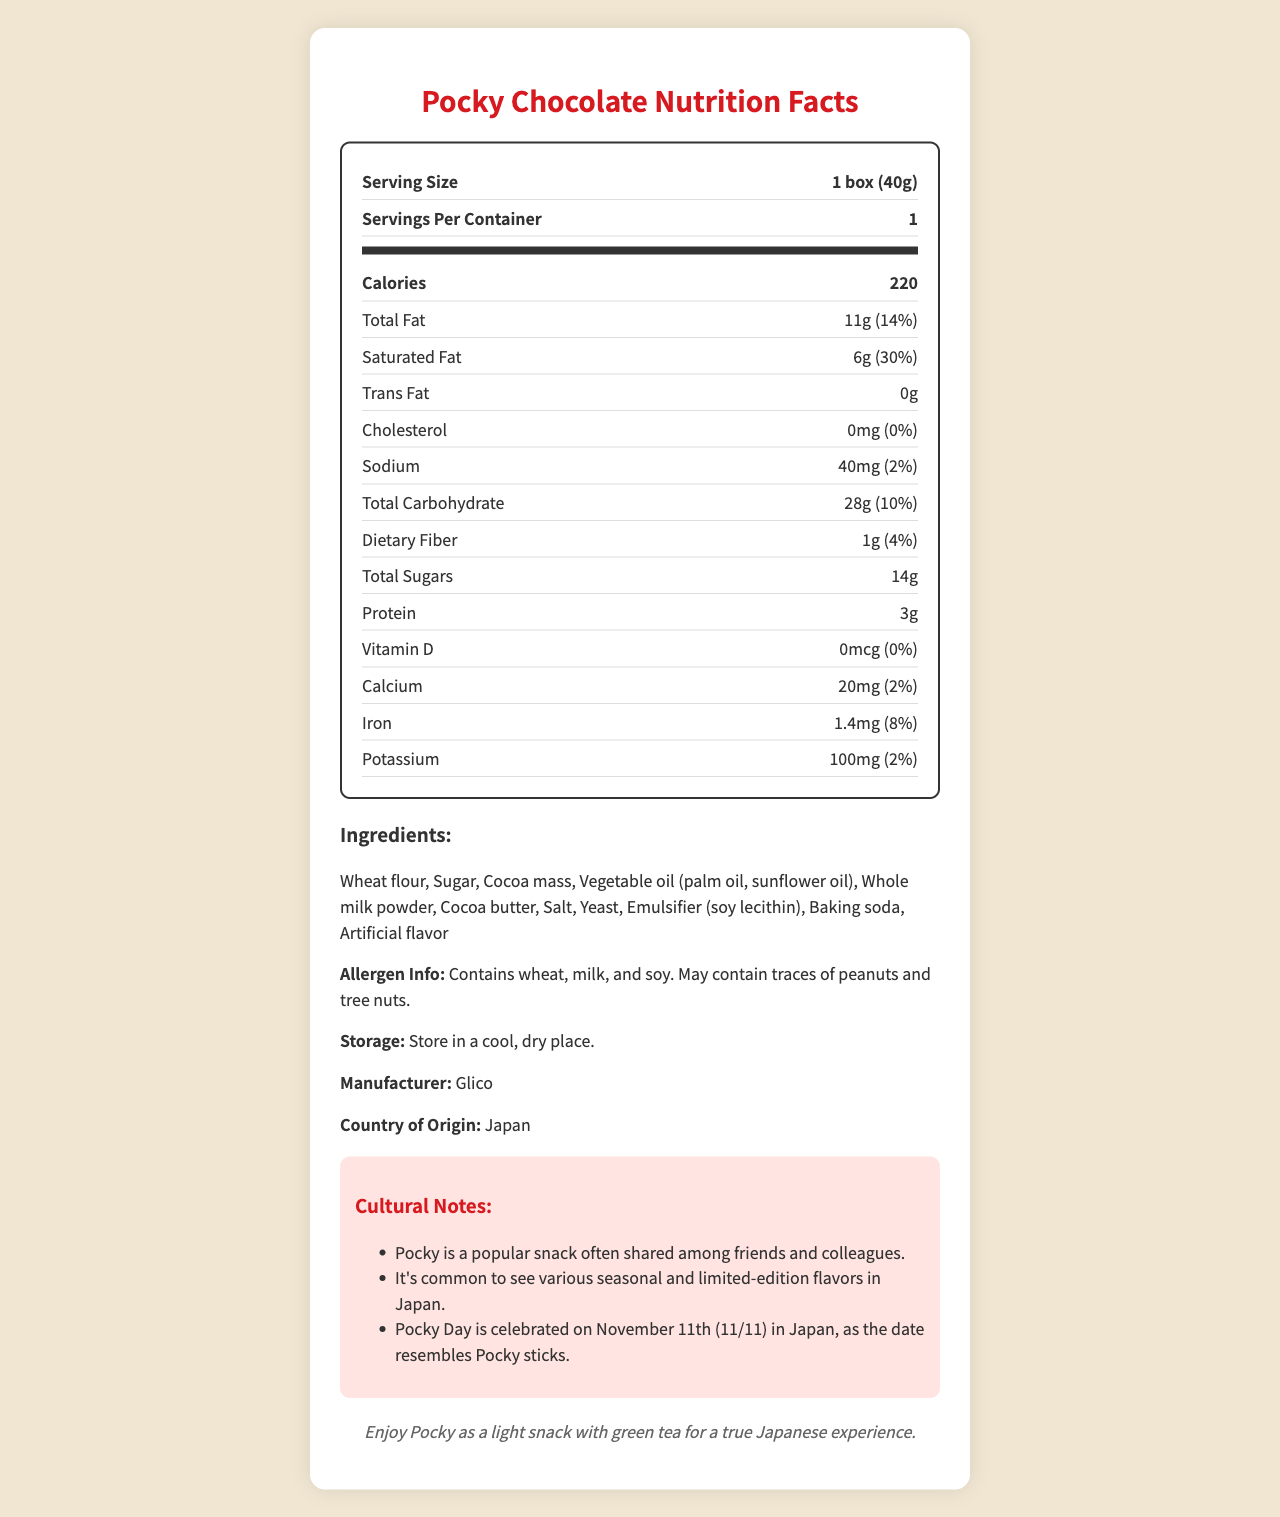what is the serving size? The serving size is stated at the top of the nutrition label: "Serving Size 1 box (40g)".
Answer: 1 box (40g) how many calories are in one serving of Pocky Chocolate? The calories per serving are listed as "220" under the Calories section of the nutrition label.
Answer: 220 what is the total fat content in one serving? The total fat content is specified as "Total Fat 11g (14%)".
Answer: 11g compare the saturated fat and trans fat content in Pocky Chocolate. The nutrition label shows "Saturated Fat 6g (30%)" and "Trans Fat 0g".
Answer: Saturated Fat: 6g, Trans Fat: 0g what are the ingredients in Pocky Chocolate? The ingredients are listed under the Ingredients section of the document.
Answer: Wheat flour, Sugar, Cocoa mass, Vegetable oil (palm oil, sunflower oil), Whole milk powder, Cocoa butter, Salt, Yeast, Emulsifier (soy lecithin), Baking soda, Artificial flavor what allergens are present in Pocky Chocolate? The allergen information states: "Contains wheat, milk, and soy. May contain traces of peanuts and tree nuts."
Answer: wheat, milk, soy, may contain traces of peanuts and tree nuts who is the manufacturer of Pocky Chocolate? The manufacturer information is given as "Glico".
Answer: Glico what is the fiber content per serving? The dietary fiber content is shown in the nutrition facts as "Dietary Fiber 1g (4%)".
Answer: 1g how much protein is in one serving of Pocky Chocolate? The protein content is listed as "Protein 3g" in the nutrition label.
Answer: 3g how much sodium does one serving contain? The sodium content is stated as "Sodium 40mg (2%)".
Answer: 40mg which vitamin is not present in Pocky Chocolate? The nutrition label shows "Vitamin D 0mcg (0%)", indicating that Vitamin D is not present.
Answer: Vitamin D what are the total carbohydrates in a serving? The total carbohydrate content is listed as "Total Carbohydrate 28g (10%)".
Answer: 28g which ingredient is not part of Pocky Chocolate? A. Wheat flour B. Cocoa mass C. Potato starch D. Yeast The ingredients listed include Wheat flour, Cocoa mass, and Yeast, but not Potato starch.
Answer: C. Potato starch how is Pocky typically enjoyed according to the document? A. With a meal B. As a light snack with green tea C. Before bedtime D. With coffee The serving suggestion at the bottom states "Enjoy Pocky as a light snack with green tea for a true Japanese experience."
Answer: B. As a light snack with green tea what cultural event is associated with Pocky in Japan? The cultural notes mention "Pocky Day is celebrated on November 11th (11/11) in Japan, as the date resembles Pocky sticks."
Answer: Pocky Day on November 11th (11/11) is there any cholesterol in Pocky Chocolate? The nutrition label indicates "Cholesterol 0mg (0%)", meaning there is no cholesterol.
Answer: No what is the origin country of Pocky Chocolate? The country of origin is listed as Japan.
Answer: Japan summarize the main details provided in the document. The summary captures the key details about the product, such as nutritional content, ingredients, allergens, and cultural notes, providing a comprehensive overview.
Answer: The document is a nutrition facts label for "Pocky Chocolate". It includes information such as serving size (1 box, 40g), calories (220 per serving), detailed nutritional values like fats, carbohydrates, protein, and various vitamins and minerals. Ingredients and allergen information are specified. It also contains cultural notes about Pocky's popularity and serving suggestions. how many varieties per container? The document does not provide information on how many different varieties are in the container. It only gives the serving size and servings per container for a single type of Pocky.
Answer: Cannot be determined 